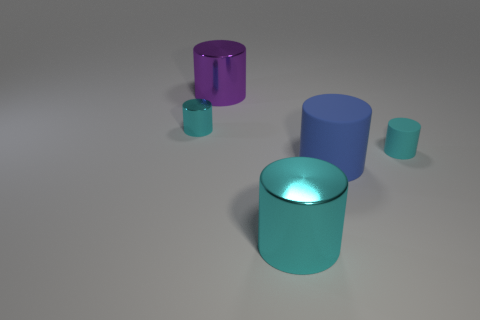Subtract all yellow cubes. How many cyan cylinders are left? 3 Subtract all blue cylinders. How many cylinders are left? 4 Subtract all purple cylinders. How many cylinders are left? 4 Subtract all blue cylinders. Subtract all blue balls. How many cylinders are left? 4 Add 5 large rubber cylinders. How many objects exist? 10 Subtract all brown cylinders. Subtract all large cyan objects. How many objects are left? 4 Add 2 big metal things. How many big metal things are left? 4 Add 2 small objects. How many small objects exist? 4 Subtract 1 purple cylinders. How many objects are left? 4 